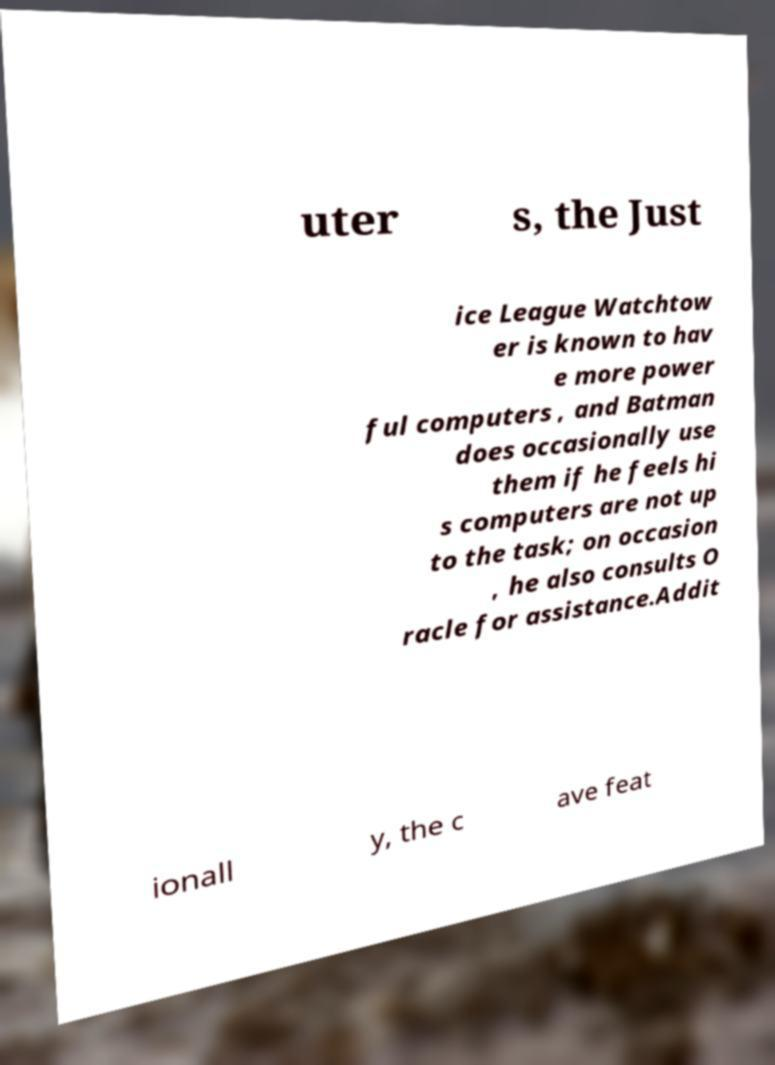Please read and relay the text visible in this image. What does it say? uter s, the Just ice League Watchtow er is known to hav e more power ful computers , and Batman does occasionally use them if he feels hi s computers are not up to the task; on occasion , he also consults O racle for assistance.Addit ionall y, the c ave feat 